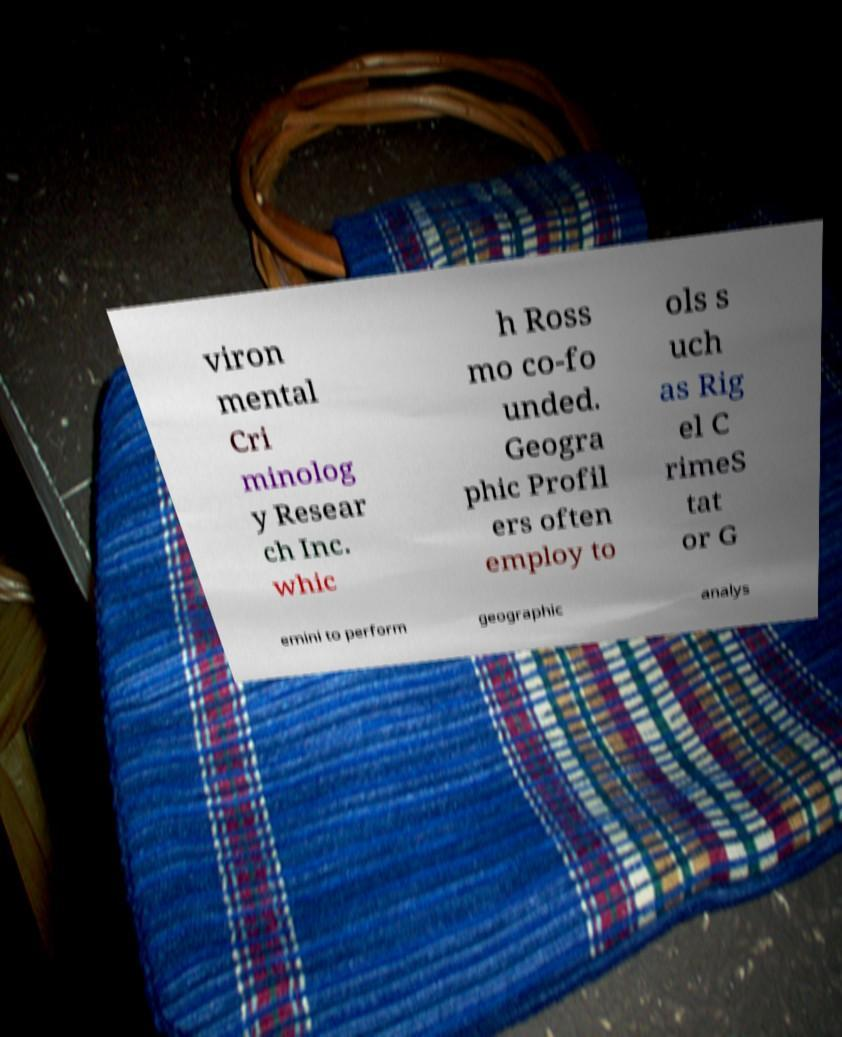Please identify and transcribe the text found in this image. viron mental Cri minolog y Resear ch Inc. whic h Ross mo co-fo unded. Geogra phic Profil ers often employ to ols s uch as Rig el C rimeS tat or G emini to perform geographic analys 